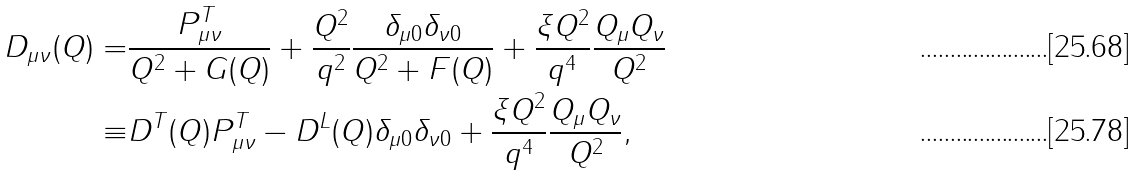<formula> <loc_0><loc_0><loc_500><loc_500>D _ { \mu \nu } ( Q ) = & \frac { P _ { \mu \nu } ^ { T } } { Q ^ { 2 } + G ( Q ) } + \frac { Q ^ { 2 } } { q ^ { 2 } } \frac { \delta _ { \mu 0 } \delta _ { \nu 0 } } { Q ^ { 2 } + F ( Q ) } + \frac { \xi Q ^ { 2 } } { q ^ { 4 } } \frac { Q _ { \mu } Q _ { \nu } } { Q ^ { 2 } } \\ \equiv & D ^ { T } ( Q ) P _ { \mu \nu } ^ { T } - D ^ { L } ( Q ) \delta _ { \mu 0 } \delta _ { \nu 0 } + \frac { \xi Q ^ { 2 } } { q ^ { 4 } } \frac { Q _ { \mu } Q _ { \nu } } { Q ^ { 2 } } ,</formula> 